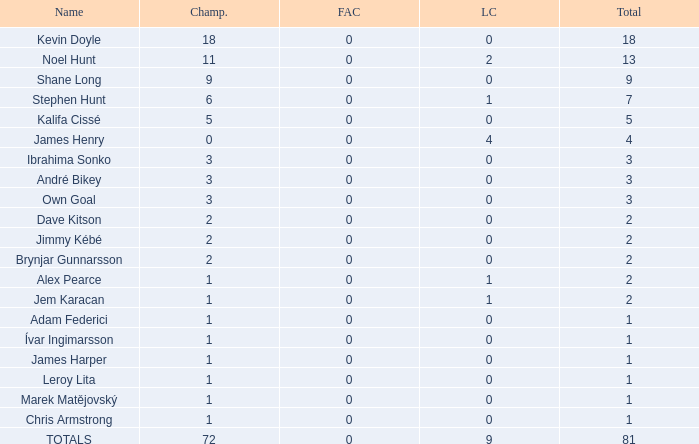What is the total championships of James Henry that has a league cup more than 1? 0.0. 